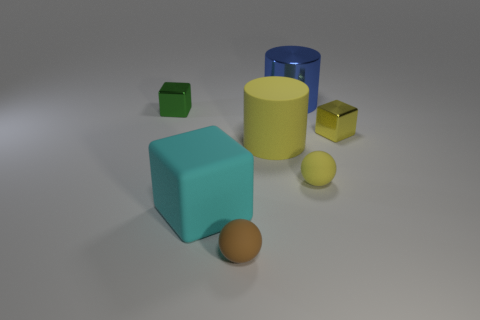Add 1 big cubes. How many objects exist? 8 Subtract all green cubes. How many cubes are left? 2 Subtract all metal cubes. How many cubes are left? 1 Subtract 1 spheres. How many spheres are left? 1 Subtract all cyan blocks. Subtract all blue balls. How many blocks are left? 2 Subtract all red cubes. How many blue cylinders are left? 1 Subtract 1 brown spheres. How many objects are left? 6 Subtract all cubes. How many objects are left? 4 Subtract all large gray shiny things. Subtract all big blue things. How many objects are left? 6 Add 4 brown things. How many brown things are left? 5 